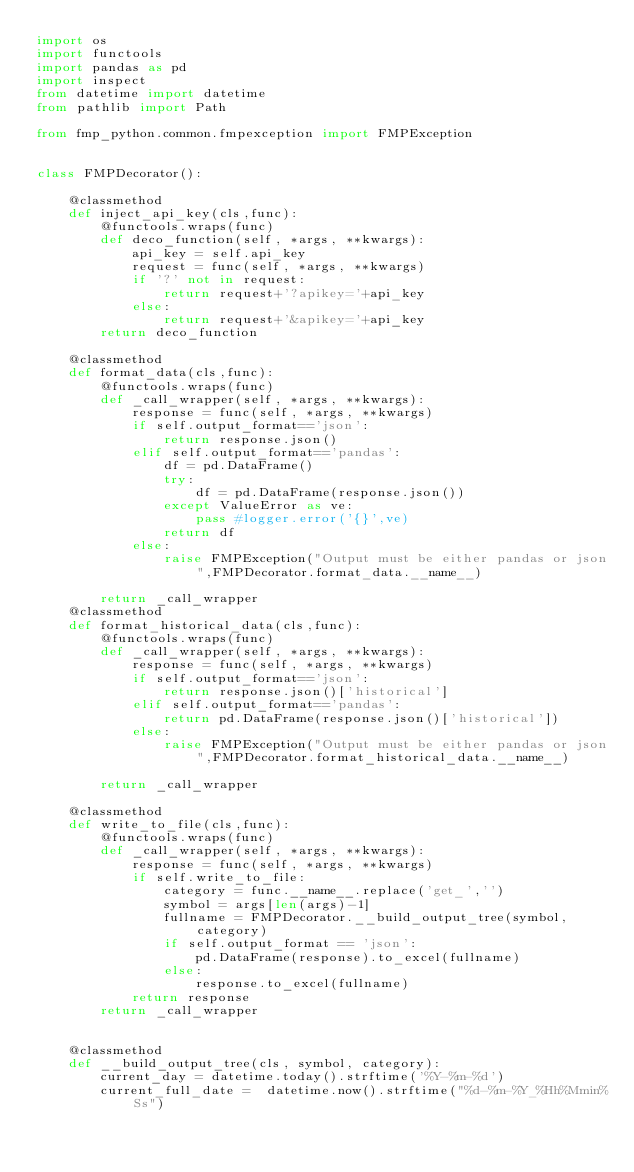<code> <loc_0><loc_0><loc_500><loc_500><_Python_>import os
import functools
import pandas as pd
import inspect
from datetime import datetime
from pathlib import Path

from fmp_python.common.fmpexception import FMPException


class FMPDecorator():

    @classmethod
    def inject_api_key(cls,func):
        @functools.wraps(func)
        def deco_function(self, *args, **kwargs):
            api_key = self.api_key
            request = func(self, *args, **kwargs)
            if '?' not in request:
                return request+'?apikey='+api_key
            else:
                return request+'&apikey='+api_key
        return deco_function
    
    @classmethod
    def format_data(cls,func):
        @functools.wraps(func)
        def _call_wrapper(self, *args, **kwargs):
            response = func(self, *args, **kwargs)
            if self.output_format=='json':
                return response.json()
            elif self.output_format=='pandas':
                df = pd.DataFrame()
                try: 
                    df = pd.DataFrame(response.json()) 
                except ValueError as ve:
                    pass #logger.error('{}',ve)
                return df 
            else:
                raise FMPException("Output must be either pandas or json",FMPDecorator.format_data.__name__) 

        return _call_wrapper
    @classmethod
    def format_historical_data(cls,func):
        @functools.wraps(func)
        def _call_wrapper(self, *args, **kwargs):
            response = func(self, *args, **kwargs)
            if self.output_format=='json':
                return response.json()['historical']
            elif self.output_format=='pandas':
                return pd.DataFrame(response.json()['historical']) 
            else:
                raise FMPException("Output must be either pandas or json",FMPDecorator.format_historical_data.__name__) 

        return _call_wrapper

    @classmethod
    def write_to_file(cls,func):
        @functools.wraps(func)
        def _call_wrapper(self, *args, **kwargs):
            response = func(self, *args, **kwargs)
            if self.write_to_file:
                category = func.__name__.replace('get_','')
                symbol = args[len(args)-1]
                fullname = FMPDecorator.__build_output_tree(symbol, category)
                if self.output_format == 'json':
                    pd.DataFrame(response).to_excel(fullname)
                else:
                    response.to_excel(fullname)
            return response
        return _call_wrapper


    @classmethod           
    def __build_output_tree(cls, symbol, category):
        current_day = datetime.today().strftime('%Y-%m-%d')
        current_full_date =  datetime.now().strftime("%d-%m-%Y_%Hh%Mmin%Ss")
        </code> 